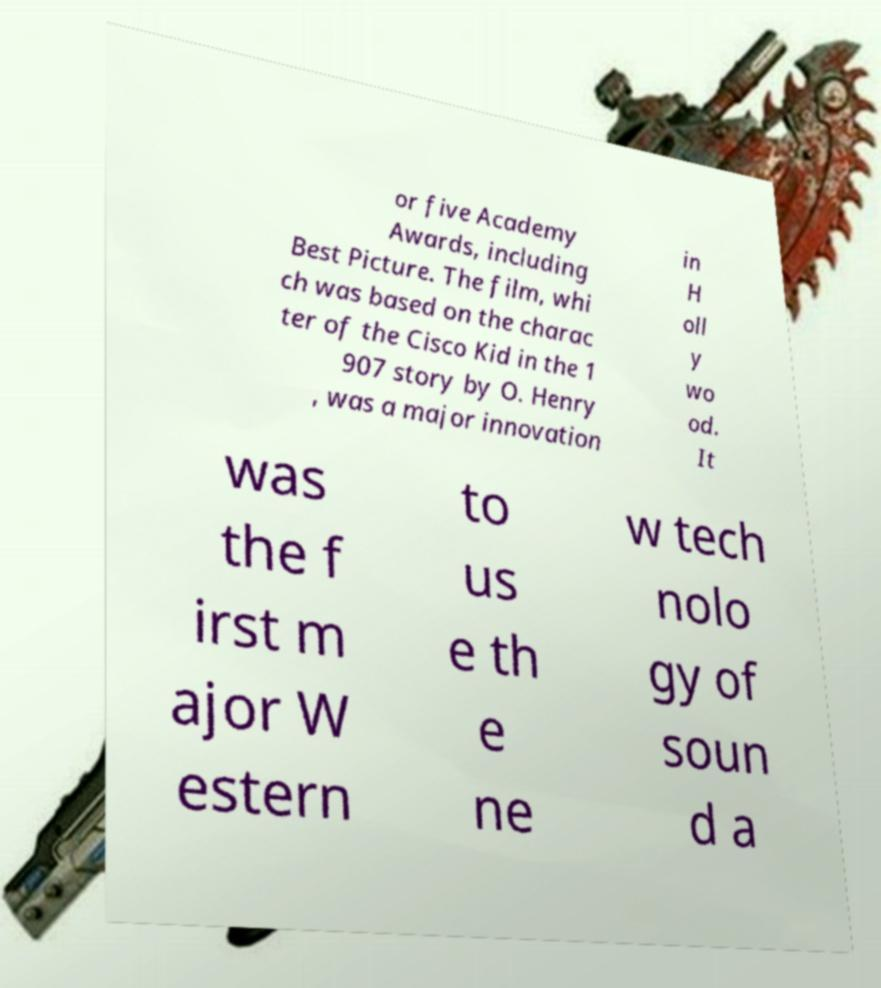For documentation purposes, I need the text within this image transcribed. Could you provide that? or five Academy Awards, including Best Picture. The film, whi ch was based on the charac ter of the Cisco Kid in the 1 907 story by O. Henry , was a major innovation in H oll y wo od. It was the f irst m ajor W estern to us e th e ne w tech nolo gy of soun d a 